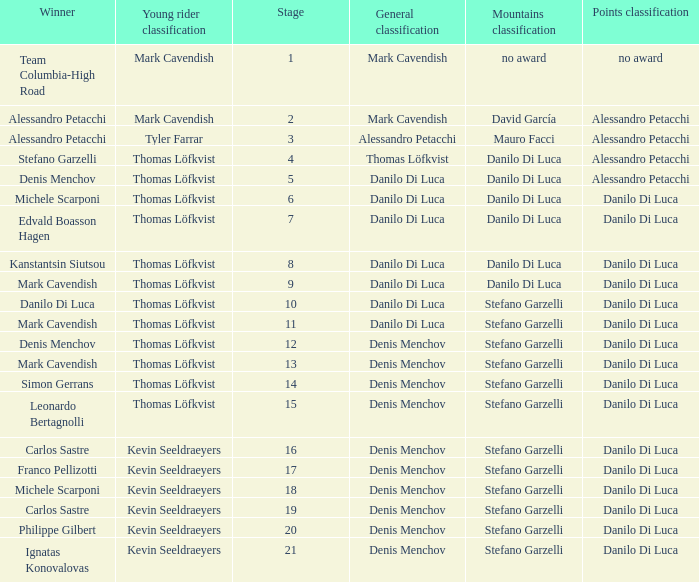When  thomas löfkvist is the general classification who is the winner? Stefano Garzelli. 